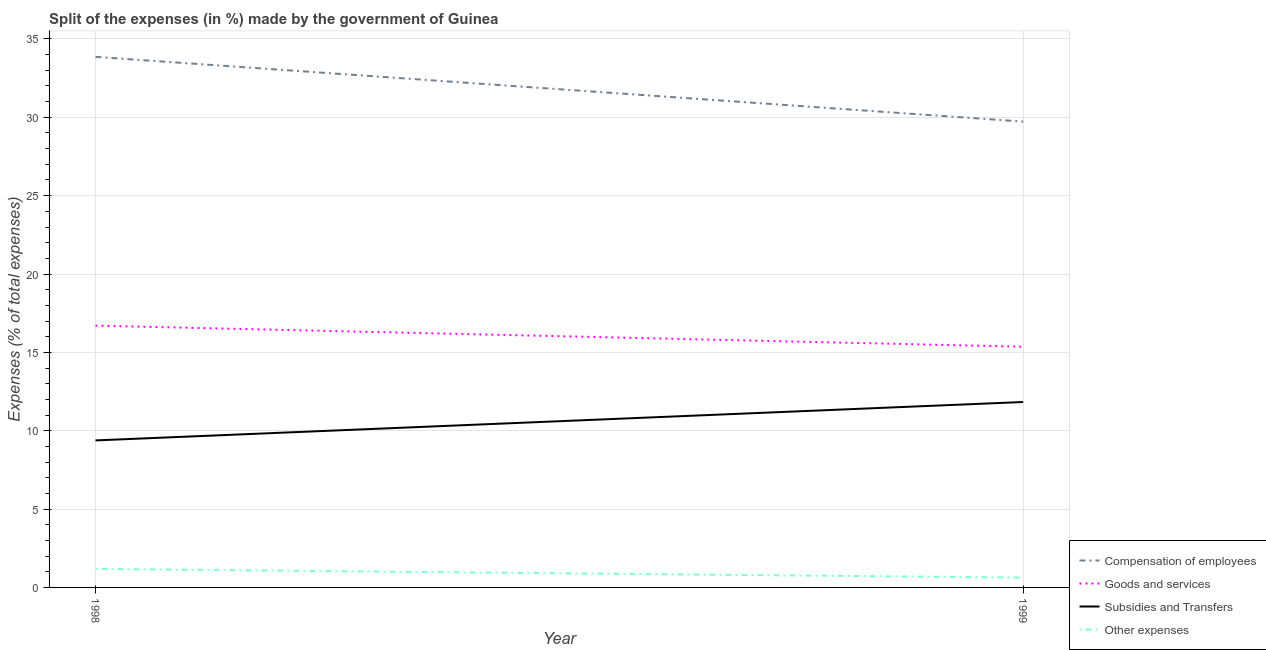Does the line corresponding to percentage of amount spent on subsidies intersect with the line corresponding to percentage of amount spent on goods and services?
Make the answer very short. No. Is the number of lines equal to the number of legend labels?
Keep it short and to the point. Yes. What is the percentage of amount spent on other expenses in 1999?
Make the answer very short. 0.63. Across all years, what is the maximum percentage of amount spent on other expenses?
Provide a short and direct response. 1.18. Across all years, what is the minimum percentage of amount spent on goods and services?
Your answer should be very brief. 15.36. What is the total percentage of amount spent on subsidies in the graph?
Keep it short and to the point. 21.21. What is the difference between the percentage of amount spent on other expenses in 1998 and that in 1999?
Offer a terse response. 0.55. What is the difference between the percentage of amount spent on other expenses in 1999 and the percentage of amount spent on subsidies in 1998?
Provide a succinct answer. -8.76. What is the average percentage of amount spent on compensation of employees per year?
Your answer should be very brief. 31.79. In the year 1998, what is the difference between the percentage of amount spent on subsidies and percentage of amount spent on other expenses?
Offer a terse response. 8.2. What is the ratio of the percentage of amount spent on subsidies in 1998 to that in 1999?
Your answer should be very brief. 0.79. Is the percentage of amount spent on goods and services in 1998 less than that in 1999?
Provide a succinct answer. No. In how many years, is the percentage of amount spent on subsidies greater than the average percentage of amount spent on subsidies taken over all years?
Your response must be concise. 1. Is it the case that in every year, the sum of the percentage of amount spent on goods and services and percentage of amount spent on other expenses is greater than the sum of percentage of amount spent on compensation of employees and percentage of amount spent on subsidies?
Provide a succinct answer. No. Is it the case that in every year, the sum of the percentage of amount spent on compensation of employees and percentage of amount spent on goods and services is greater than the percentage of amount spent on subsidies?
Give a very brief answer. Yes. How many lines are there?
Provide a succinct answer. 4. Are the values on the major ticks of Y-axis written in scientific E-notation?
Provide a short and direct response. No. Where does the legend appear in the graph?
Your answer should be very brief. Bottom right. How many legend labels are there?
Make the answer very short. 4. What is the title of the graph?
Provide a short and direct response. Split of the expenses (in %) made by the government of Guinea. Does "Gender equality" appear as one of the legend labels in the graph?
Provide a succinct answer. No. What is the label or title of the Y-axis?
Offer a terse response. Expenses (% of total expenses). What is the Expenses (% of total expenses) in Compensation of employees in 1998?
Offer a very short reply. 33.86. What is the Expenses (% of total expenses) in Goods and services in 1998?
Ensure brevity in your answer.  16.7. What is the Expenses (% of total expenses) of Subsidies and Transfers in 1998?
Your answer should be compact. 9.38. What is the Expenses (% of total expenses) of Other expenses in 1998?
Keep it short and to the point. 1.18. What is the Expenses (% of total expenses) in Compensation of employees in 1999?
Offer a very short reply. 29.73. What is the Expenses (% of total expenses) of Goods and services in 1999?
Keep it short and to the point. 15.36. What is the Expenses (% of total expenses) of Subsidies and Transfers in 1999?
Provide a short and direct response. 11.83. What is the Expenses (% of total expenses) in Other expenses in 1999?
Ensure brevity in your answer.  0.63. Across all years, what is the maximum Expenses (% of total expenses) of Compensation of employees?
Make the answer very short. 33.86. Across all years, what is the maximum Expenses (% of total expenses) in Goods and services?
Provide a short and direct response. 16.7. Across all years, what is the maximum Expenses (% of total expenses) in Subsidies and Transfers?
Keep it short and to the point. 11.83. Across all years, what is the maximum Expenses (% of total expenses) in Other expenses?
Make the answer very short. 1.18. Across all years, what is the minimum Expenses (% of total expenses) in Compensation of employees?
Provide a succinct answer. 29.73. Across all years, what is the minimum Expenses (% of total expenses) of Goods and services?
Ensure brevity in your answer.  15.36. Across all years, what is the minimum Expenses (% of total expenses) in Subsidies and Transfers?
Make the answer very short. 9.38. Across all years, what is the minimum Expenses (% of total expenses) in Other expenses?
Your response must be concise. 0.63. What is the total Expenses (% of total expenses) in Compensation of employees in the graph?
Provide a succinct answer. 63.58. What is the total Expenses (% of total expenses) of Goods and services in the graph?
Keep it short and to the point. 32.06. What is the total Expenses (% of total expenses) of Subsidies and Transfers in the graph?
Offer a very short reply. 21.21. What is the total Expenses (% of total expenses) in Other expenses in the graph?
Your answer should be very brief. 1.81. What is the difference between the Expenses (% of total expenses) of Compensation of employees in 1998 and that in 1999?
Make the answer very short. 4.13. What is the difference between the Expenses (% of total expenses) of Goods and services in 1998 and that in 1999?
Your answer should be compact. 1.35. What is the difference between the Expenses (% of total expenses) of Subsidies and Transfers in 1998 and that in 1999?
Offer a terse response. -2.45. What is the difference between the Expenses (% of total expenses) of Other expenses in 1998 and that in 1999?
Give a very brief answer. 0.55. What is the difference between the Expenses (% of total expenses) of Compensation of employees in 1998 and the Expenses (% of total expenses) of Goods and services in 1999?
Your answer should be very brief. 18.5. What is the difference between the Expenses (% of total expenses) in Compensation of employees in 1998 and the Expenses (% of total expenses) in Subsidies and Transfers in 1999?
Provide a succinct answer. 22.03. What is the difference between the Expenses (% of total expenses) in Compensation of employees in 1998 and the Expenses (% of total expenses) in Other expenses in 1999?
Offer a terse response. 33.23. What is the difference between the Expenses (% of total expenses) of Goods and services in 1998 and the Expenses (% of total expenses) of Subsidies and Transfers in 1999?
Your response must be concise. 4.87. What is the difference between the Expenses (% of total expenses) in Goods and services in 1998 and the Expenses (% of total expenses) in Other expenses in 1999?
Give a very brief answer. 16.08. What is the difference between the Expenses (% of total expenses) in Subsidies and Transfers in 1998 and the Expenses (% of total expenses) in Other expenses in 1999?
Your answer should be compact. 8.76. What is the average Expenses (% of total expenses) of Compensation of employees per year?
Give a very brief answer. 31.79. What is the average Expenses (% of total expenses) of Goods and services per year?
Your response must be concise. 16.03. What is the average Expenses (% of total expenses) of Subsidies and Transfers per year?
Provide a short and direct response. 10.61. What is the average Expenses (% of total expenses) of Other expenses per year?
Your answer should be compact. 0.9. In the year 1998, what is the difference between the Expenses (% of total expenses) in Compensation of employees and Expenses (% of total expenses) in Goods and services?
Ensure brevity in your answer.  17.15. In the year 1998, what is the difference between the Expenses (% of total expenses) of Compensation of employees and Expenses (% of total expenses) of Subsidies and Transfers?
Provide a succinct answer. 24.48. In the year 1998, what is the difference between the Expenses (% of total expenses) of Compensation of employees and Expenses (% of total expenses) of Other expenses?
Provide a succinct answer. 32.68. In the year 1998, what is the difference between the Expenses (% of total expenses) in Goods and services and Expenses (% of total expenses) in Subsidies and Transfers?
Offer a terse response. 7.32. In the year 1998, what is the difference between the Expenses (% of total expenses) of Goods and services and Expenses (% of total expenses) of Other expenses?
Give a very brief answer. 15.52. In the year 1998, what is the difference between the Expenses (% of total expenses) in Subsidies and Transfers and Expenses (% of total expenses) in Other expenses?
Offer a terse response. 8.2. In the year 1999, what is the difference between the Expenses (% of total expenses) in Compensation of employees and Expenses (% of total expenses) in Goods and services?
Keep it short and to the point. 14.37. In the year 1999, what is the difference between the Expenses (% of total expenses) in Compensation of employees and Expenses (% of total expenses) in Subsidies and Transfers?
Offer a very short reply. 17.89. In the year 1999, what is the difference between the Expenses (% of total expenses) in Compensation of employees and Expenses (% of total expenses) in Other expenses?
Offer a very short reply. 29.1. In the year 1999, what is the difference between the Expenses (% of total expenses) of Goods and services and Expenses (% of total expenses) of Subsidies and Transfers?
Provide a short and direct response. 3.53. In the year 1999, what is the difference between the Expenses (% of total expenses) in Goods and services and Expenses (% of total expenses) in Other expenses?
Your answer should be compact. 14.73. In the year 1999, what is the difference between the Expenses (% of total expenses) of Subsidies and Transfers and Expenses (% of total expenses) of Other expenses?
Offer a terse response. 11.21. What is the ratio of the Expenses (% of total expenses) in Compensation of employees in 1998 to that in 1999?
Your answer should be compact. 1.14. What is the ratio of the Expenses (% of total expenses) in Goods and services in 1998 to that in 1999?
Make the answer very short. 1.09. What is the ratio of the Expenses (% of total expenses) of Subsidies and Transfers in 1998 to that in 1999?
Offer a very short reply. 0.79. What is the ratio of the Expenses (% of total expenses) of Other expenses in 1998 to that in 1999?
Give a very brief answer. 1.88. What is the difference between the highest and the second highest Expenses (% of total expenses) in Compensation of employees?
Offer a terse response. 4.13. What is the difference between the highest and the second highest Expenses (% of total expenses) of Goods and services?
Provide a short and direct response. 1.35. What is the difference between the highest and the second highest Expenses (% of total expenses) in Subsidies and Transfers?
Provide a succinct answer. 2.45. What is the difference between the highest and the second highest Expenses (% of total expenses) of Other expenses?
Give a very brief answer. 0.55. What is the difference between the highest and the lowest Expenses (% of total expenses) of Compensation of employees?
Offer a terse response. 4.13. What is the difference between the highest and the lowest Expenses (% of total expenses) in Goods and services?
Make the answer very short. 1.35. What is the difference between the highest and the lowest Expenses (% of total expenses) of Subsidies and Transfers?
Provide a succinct answer. 2.45. What is the difference between the highest and the lowest Expenses (% of total expenses) in Other expenses?
Your answer should be compact. 0.55. 